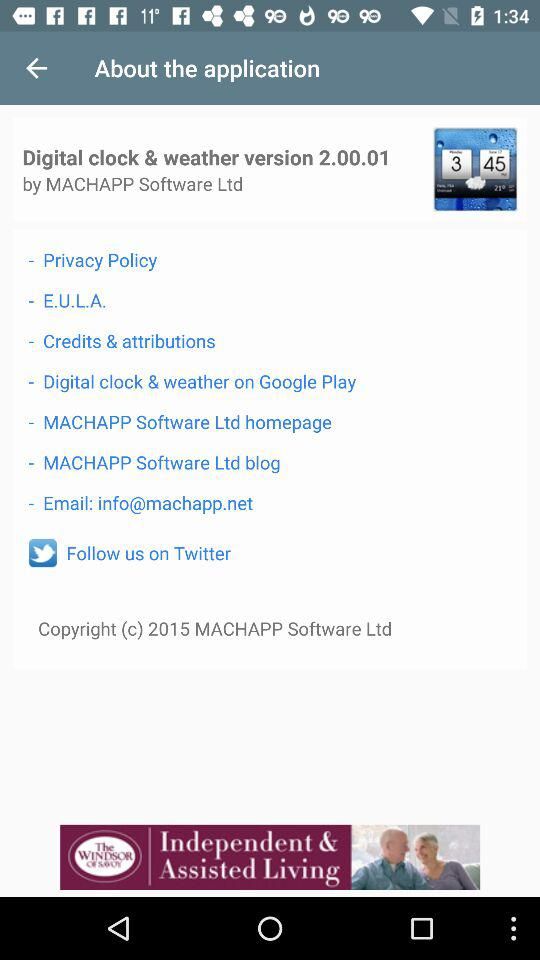What is the email address? The email address is info@machapp.net. 